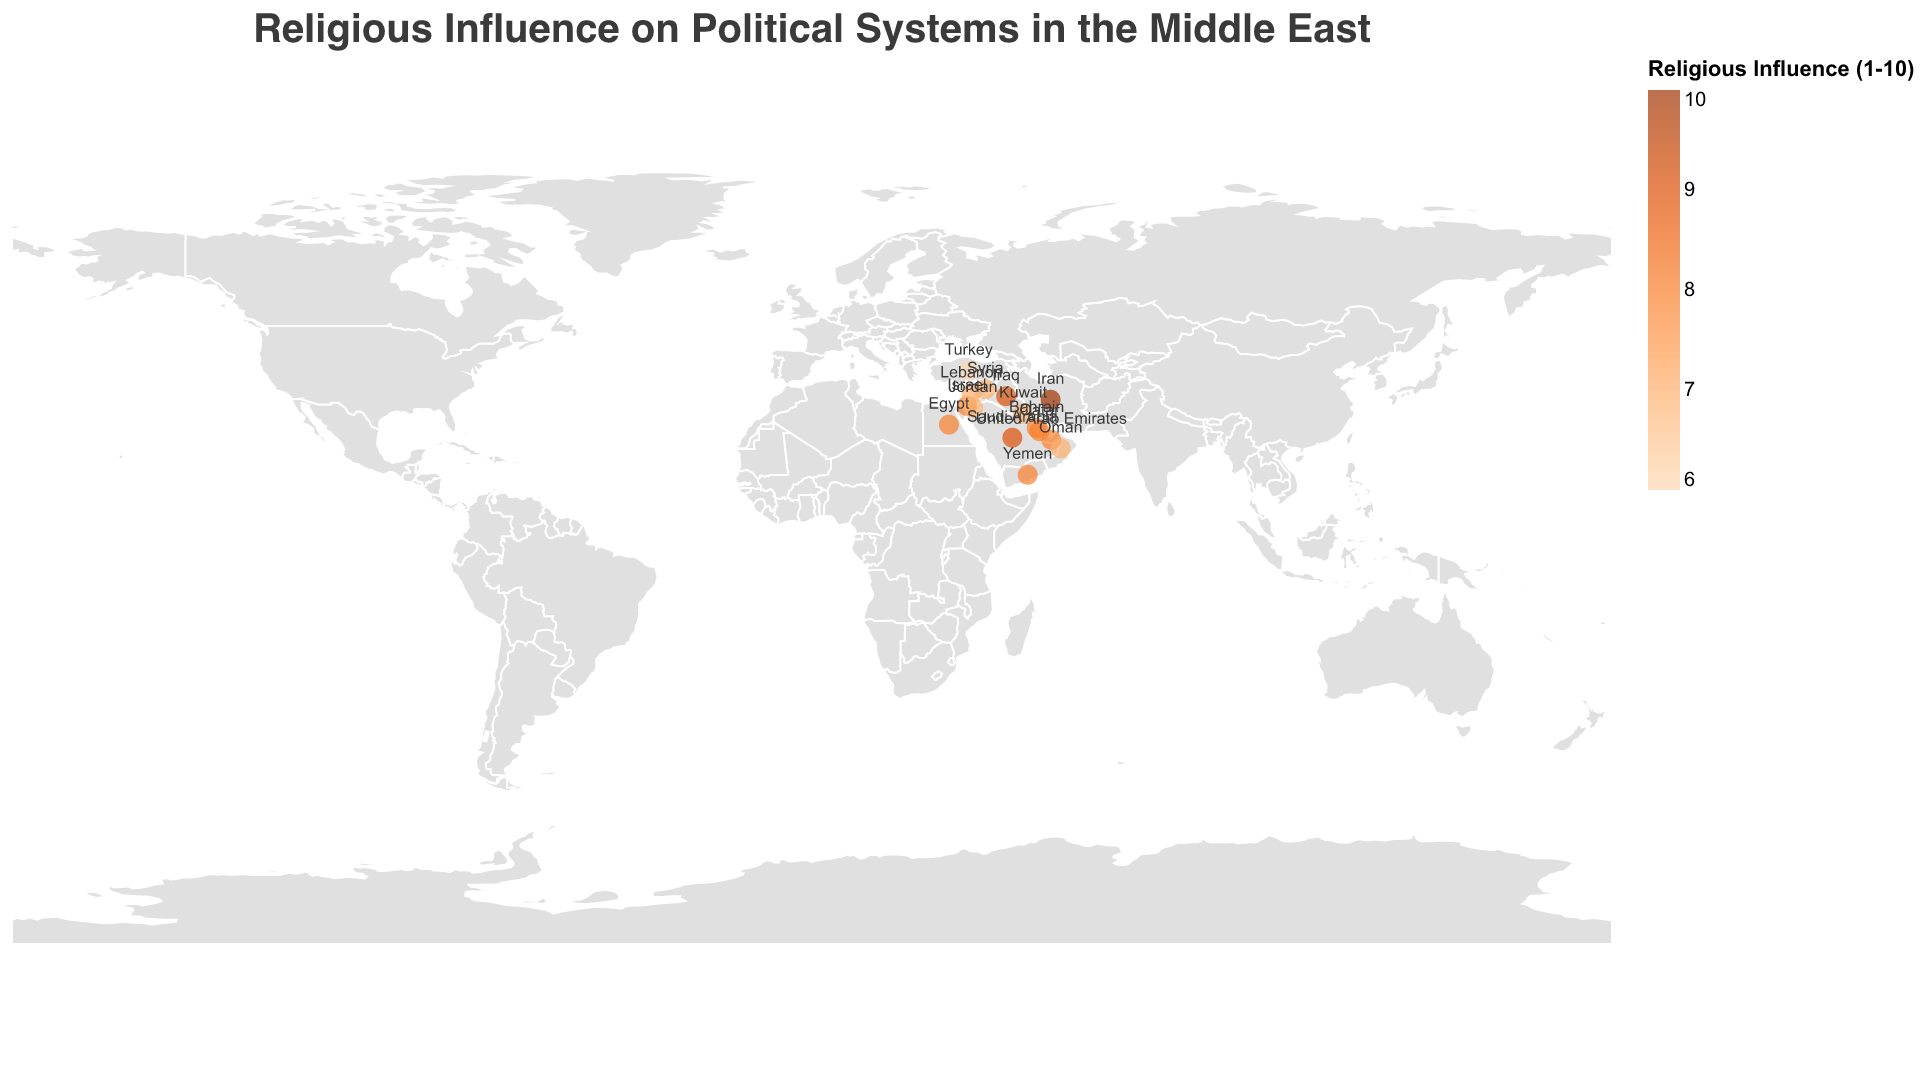What is the dominant religion in Saudi Arabia? The figure indicates the dominant religion for each country in the Middle East, and for Saudi Arabia, the stated dominant religion is "Islam (Sunni)."
Answer: Islam (Sunni) Which country has the highest religious influence score? The figure has a color scale that shows religious influence scores ranging from 1 to 10. Iran has the darkest shade of orange, which indicates the highest score of 10.
Answer: Iran Which country combines both Islam and Christianity as dominant religions? By looking at the labels in the figure, Lebanon is the country where both Islam and Christianity are dominant.
Answer: Lebanon Between Iraq and Turkey, which country has higher religious influence? The figure shows the religious influence scores. Iraq has a score of 9, while Turkey has a score of 6.
Answer: Iraq How many countries have a religious influence score of 8? Looking at the color gradient and labels, the countries with a score of 8 are Israel, Egypt, UAE, Bahrain, Yemen, and Qatar.
Answer: 6 Which countries have a religious influence score of 7 and what are their political ideologies? By examining the figure, the countries with a religious influence score of 7 are Lebanon, Jordan, Kuwait, Oman, and Syria, with political ideologies: Confessionalism, Constitutional Monarchy, Constitutional Monarchy, Absolute Monarchy, and Authoritarian, respectively.
Answer: Lebanon - Confessionalism, Jordan - Constitutional Monarchy, Kuwait - Constitutional Monarchy, Oman - Absolute Monarchy, Syria - Authoritarian What is the median religious influence score of all countries in the figure? To find the median, sort the scores (7, 7, 7, 7, 7, 8, 8, 8, 8, 8, 9, 9, 10), the middle value in this ordered list is 8.
Answer: 8 Which country with a theocratic republic political ideology has the highest religious influence? The figure shows that Iran, which has a theocratic republic ideology also has the highest religious influence of 10.
Answer: Iran Compare the religious influence of Sunni-majority countries: Which one has the lowest score, and which one has the highest? By examining the figure, Turkey has the lowest score of 6 among Sunni-majority countries, while Saudi Arabia and Iraq both share the highest score of 9.
Answer: Turkey (lowest), Saudi Arabia and Iraq (highest) Which country with an absolute monarchy political ideology has the highest religious influence? The countries with an absolute monarchy are Oman and Qatar. Among them, Qatar has the higher score of 8.
Answer: Qatar 